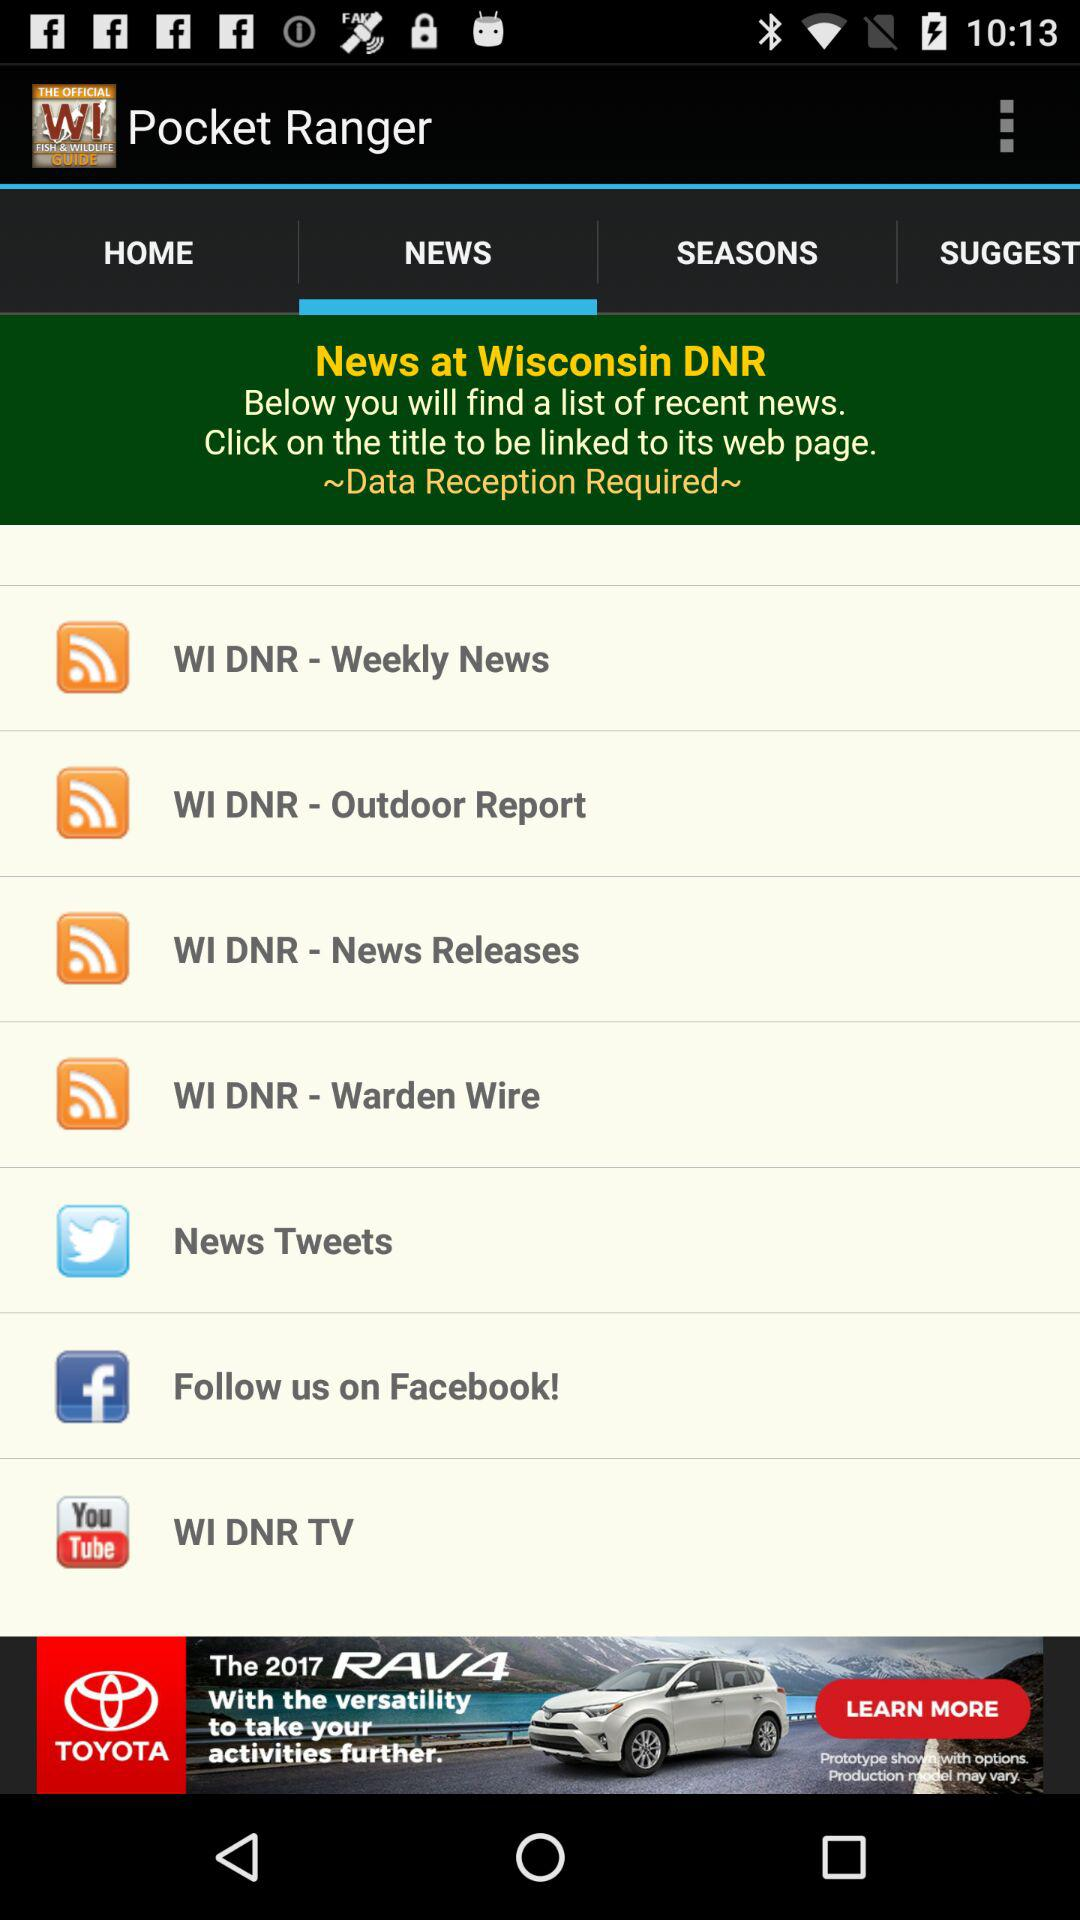What tab is selected for Pocket Ranger? The selected tab is "NEWS". 